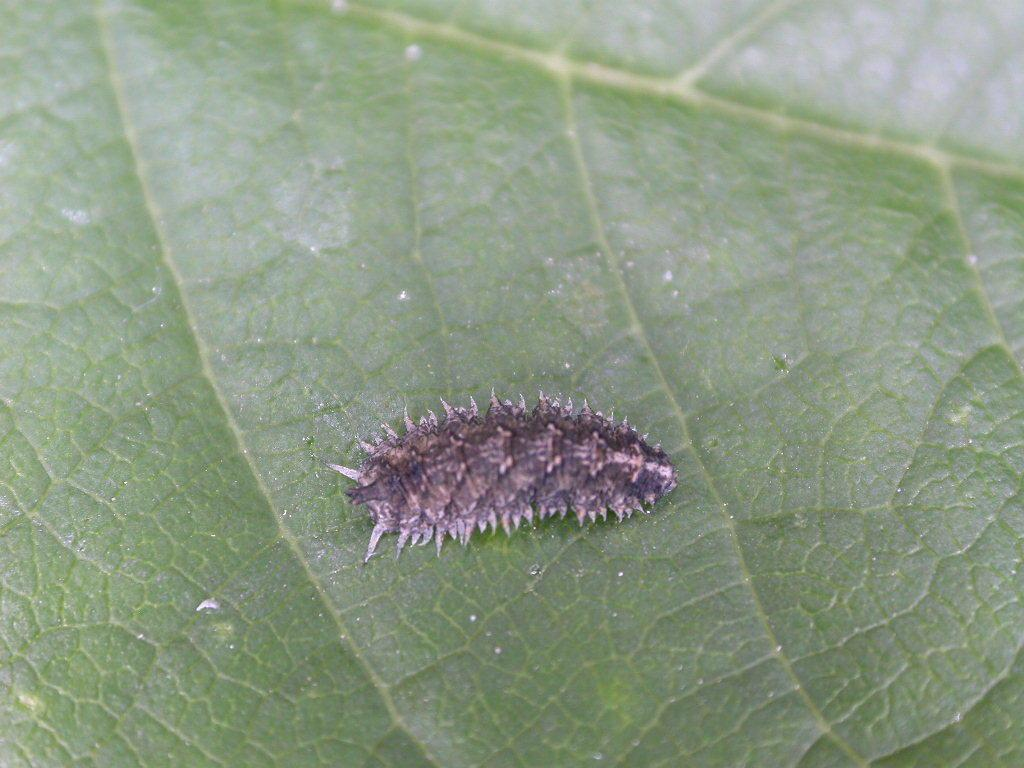What type of plant material is present in the image? There is a green leaf in the image. Is there any other living organism present on the leaf? Yes, there is an insect on the leaf in the image. What type of secretary can be seen working in the image? There is no secretary present in the image; it features a green leaf with an insect on it. How many buckets are visible in the image? There are no buckets present in the image. 